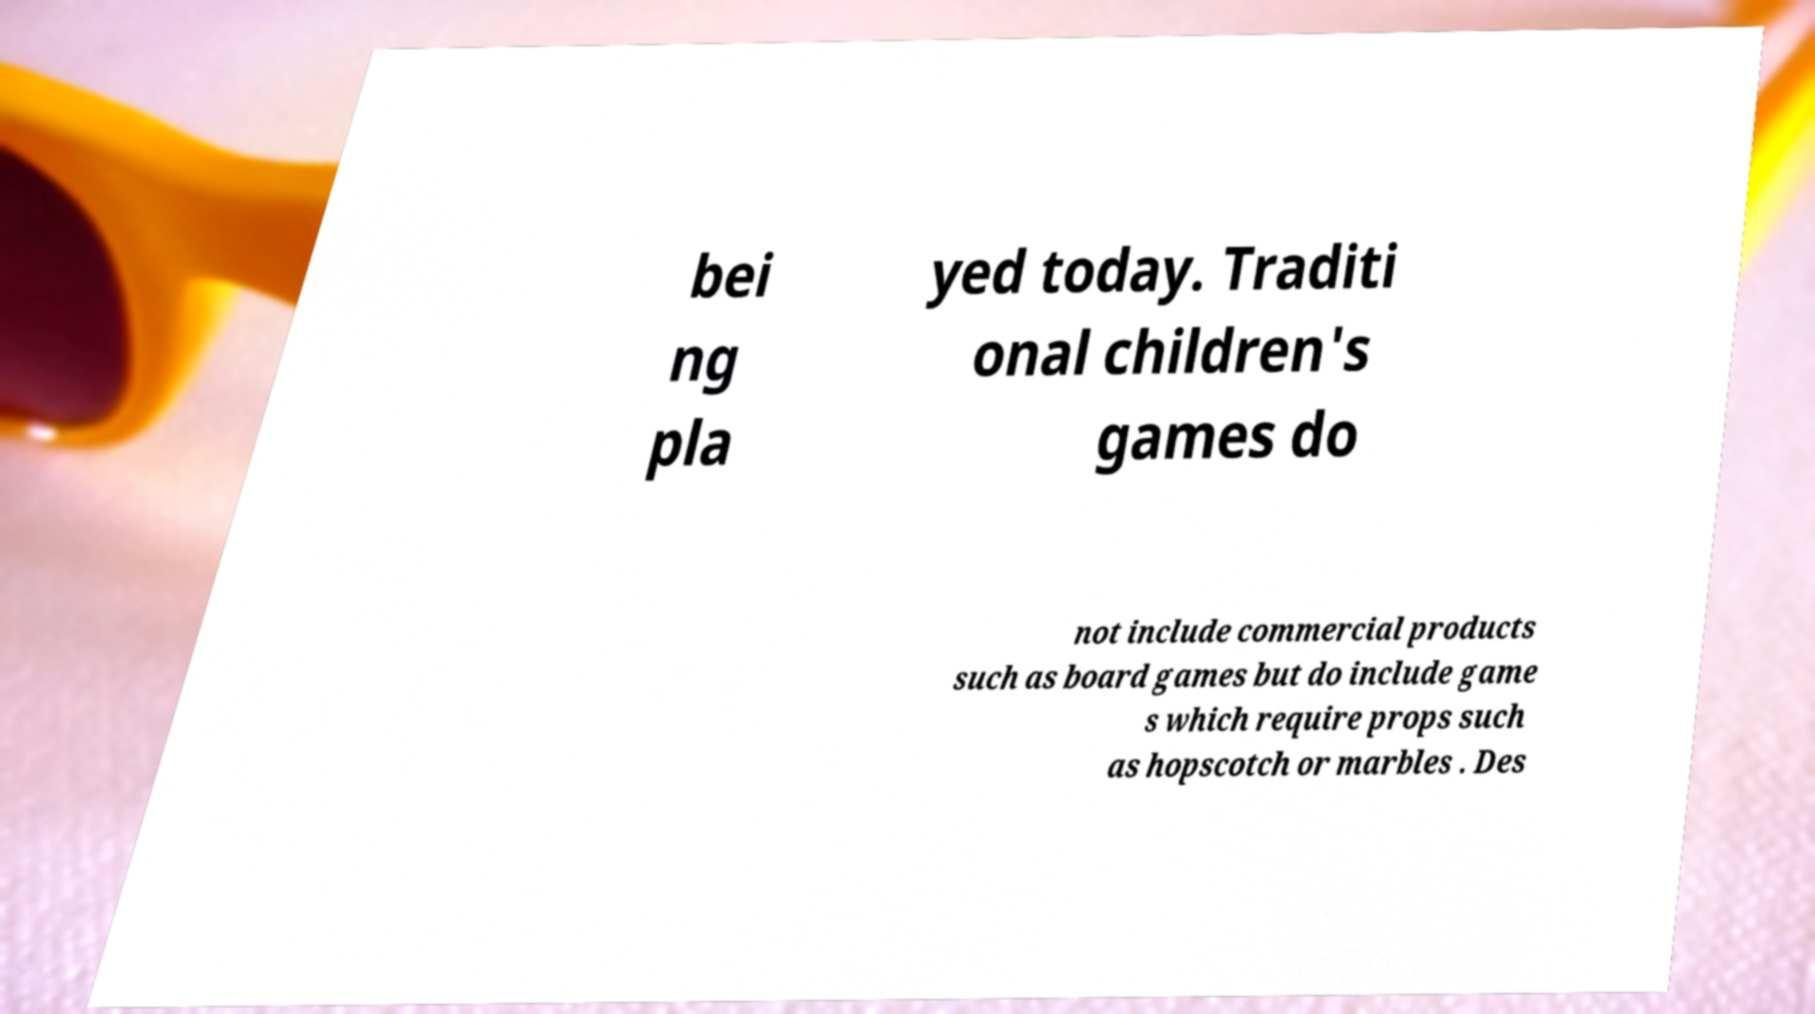Please identify and transcribe the text found in this image. bei ng pla yed today. Traditi onal children's games do not include commercial products such as board games but do include game s which require props such as hopscotch or marbles . Des 